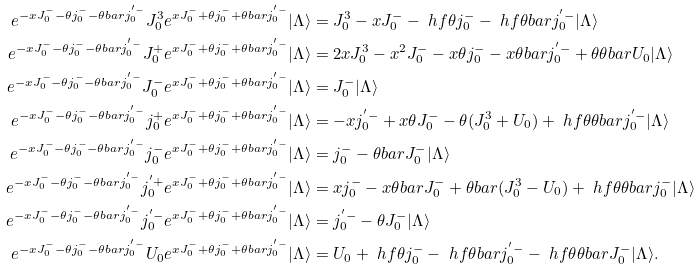Convert formula to latex. <formula><loc_0><loc_0><loc_500><loc_500>e ^ { - x J _ { 0 } ^ { - } - \theta j _ { 0 } ^ { - } - \theta b a r j _ { 0 } ^ { ^ { \prime } - } } J _ { 0 } ^ { 3 } e ^ { x J _ { 0 } ^ { - } + \theta j _ { 0 } ^ { - } + \theta b a r j _ { 0 } ^ { ^ { \prime } - } } | \Lambda \rangle & = J _ { 0 } ^ { 3 } - x J _ { 0 } ^ { - } - \ h f \theta j _ { 0 } ^ { - } - \ h f \theta b a r j _ { 0 } ^ { ^ { \prime } - } | \Lambda \rangle \\ e ^ { - x J _ { 0 } ^ { - } - \theta j _ { 0 } ^ { - } - \theta b a r j _ { 0 } ^ { ^ { \prime } - } } J _ { 0 } ^ { + } e ^ { x J _ { 0 } ^ { - } + \theta j _ { 0 } ^ { - } + \theta b a r j _ { 0 } ^ { ^ { \prime } - } } | \Lambda \rangle & = 2 x J _ { 0 } ^ { 3 } - x ^ { 2 } J _ { 0 } ^ { - } - x \theta j _ { 0 } ^ { - } - x \theta b a r j _ { 0 } ^ { ^ { \prime } - } + \theta \theta b a r U _ { 0 } | \Lambda \rangle \\ e ^ { - x J _ { 0 } ^ { - } - \theta j _ { 0 } ^ { - } - \theta b a r j _ { 0 } ^ { ^ { \prime } - } } J _ { 0 } ^ { - } e ^ { x J _ { 0 } ^ { - } + \theta j _ { 0 } ^ { - } + \theta b a r j _ { 0 } ^ { ^ { \prime } - } } | \Lambda \rangle & = J _ { 0 } ^ { - } | \Lambda \rangle \\ e ^ { - x J _ { 0 } ^ { - } - \theta j _ { 0 } ^ { - } - \theta b a r j _ { 0 } ^ { ^ { \prime } - } } j _ { 0 } ^ { + } e ^ { x J _ { 0 } ^ { - } + \theta j _ { 0 } ^ { - } + \theta b a r j _ { 0 } ^ { ^ { \prime } - } } | \Lambda \rangle & = - x j _ { 0 } ^ { ^ { \prime } - } + x \theta J _ { 0 } ^ { - } - \theta ( J _ { 0 } ^ { 3 } + U _ { 0 } ) + \ h f \theta \theta b a r j _ { 0 } ^ { ^ { \prime } - } | \Lambda \rangle \\ e ^ { - x J _ { 0 } ^ { - } - \theta j _ { 0 } ^ { - } - \theta b a r j _ { 0 } ^ { ^ { \prime } - } } j _ { 0 } ^ { - } e ^ { x J _ { 0 } ^ { - } + \theta j _ { 0 } ^ { - } + \theta b a r j _ { 0 } ^ { ^ { \prime } - } } | \Lambda \rangle & = j _ { 0 } ^ { - } - \theta b a r J _ { 0 } ^ { - } | \Lambda \rangle \\ e ^ { - x J _ { 0 } ^ { - } - \theta j _ { 0 } ^ { - } - \theta b a r j _ { 0 } ^ { ^ { \prime } - } } j _ { 0 } ^ { ^ { \prime } + } e ^ { x J _ { 0 } ^ { - } + \theta j _ { 0 } ^ { - } + \theta b a r j _ { 0 } ^ { ^ { \prime } - } } | \Lambda \rangle & = x j _ { 0 } ^ { - } - x \theta b a r J _ { 0 } ^ { - } + \theta b a r ( J _ { 0 } ^ { 3 } - U _ { 0 } ) + \ h f \theta \theta b a r j _ { 0 } ^ { - } | \Lambda \rangle \\ e ^ { - x J _ { 0 } ^ { - } - \theta j _ { 0 } ^ { - } - \theta b a r j _ { 0 } ^ { ^ { \prime } - } } j _ { 0 } ^ { ^ { \prime } - } e ^ { x J _ { 0 } ^ { - } + \theta j _ { 0 } ^ { - } + \theta b a r j _ { 0 } ^ { ^ { \prime } - } } | \Lambda \rangle & = j _ { 0 } ^ { ^ { \prime } - } - \theta J _ { 0 } ^ { - } | \Lambda \rangle \\ e ^ { - x J _ { 0 } ^ { - } - \theta j _ { 0 } ^ { - } - \theta b a r j _ { 0 } ^ { ^ { \prime } - } } U _ { 0 } e ^ { x J _ { 0 } ^ { - } + \theta j _ { 0 } ^ { - } + \theta b a r j _ { 0 } ^ { ^ { \prime } - } } | \Lambda \rangle & = U _ { 0 } + \ h f \theta j _ { 0 } ^ { - } - \ h f \theta b a r j _ { 0 } ^ { ^ { \prime } - } - \ h f \theta \theta b a r J _ { 0 } ^ { - } | \Lambda \rangle .</formula> 